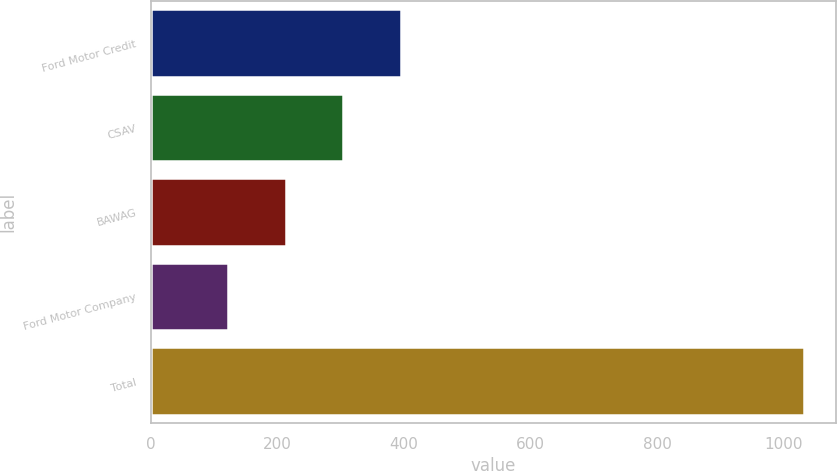Convert chart. <chart><loc_0><loc_0><loc_500><loc_500><bar_chart><fcel>Ford Motor Credit<fcel>CSAV<fcel>BAWAG<fcel>Ford Motor Company<fcel>Total<nl><fcel>395<fcel>304<fcel>213<fcel>122<fcel>1032<nl></chart> 